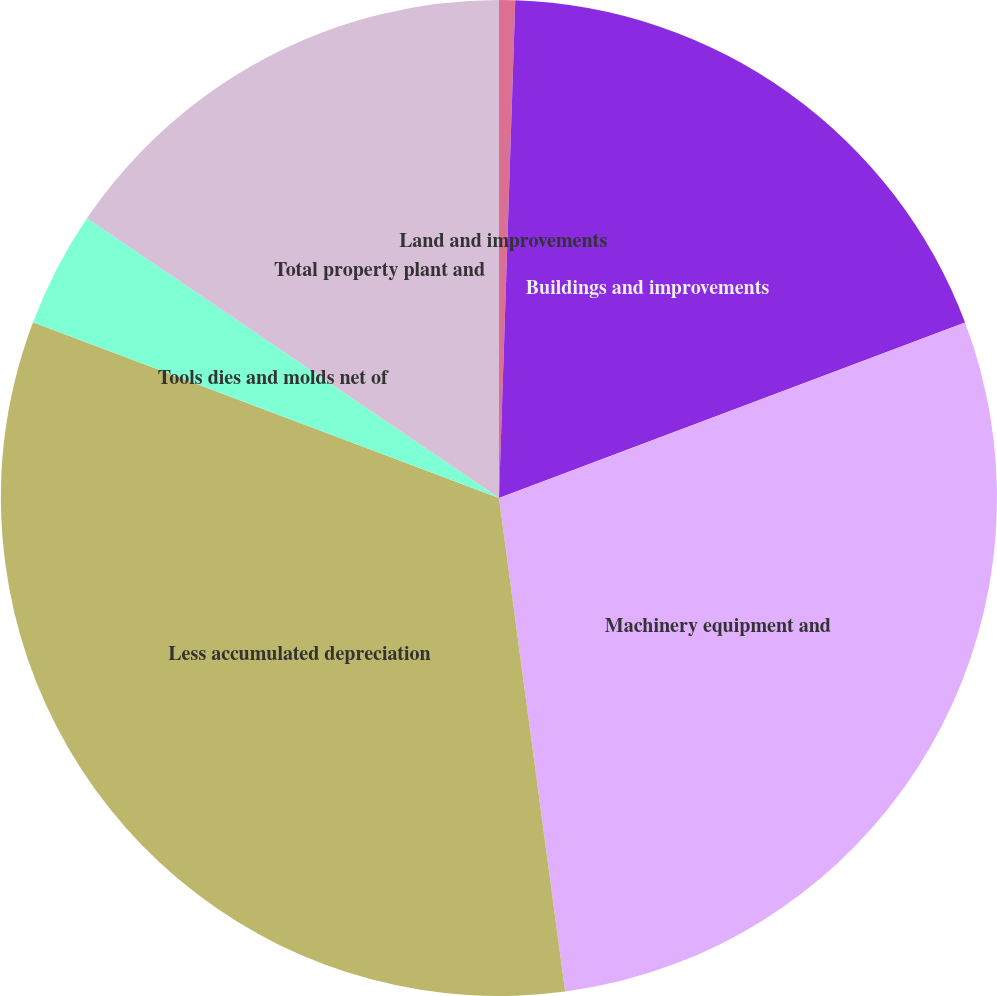Convert chart to OTSL. <chart><loc_0><loc_0><loc_500><loc_500><pie_chart><fcel>Land and improvements<fcel>Buildings and improvements<fcel>Machinery equipment and<fcel>Less accumulated depreciation<fcel>Tools dies and molds net of<fcel>Total property plant and<nl><fcel>0.52%<fcel>18.75%<fcel>28.61%<fcel>32.86%<fcel>3.75%<fcel>15.51%<nl></chart> 